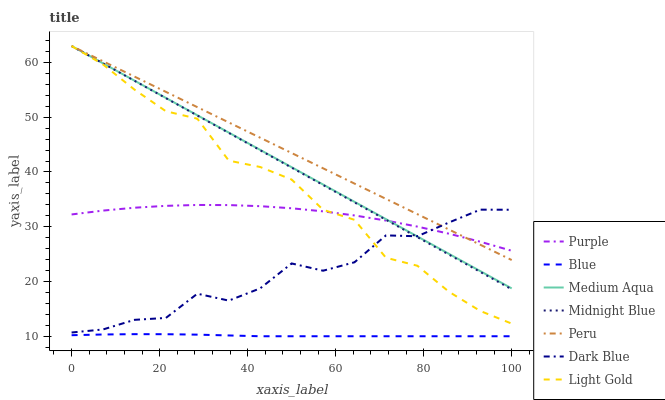Does Midnight Blue have the minimum area under the curve?
Answer yes or no. No. Does Midnight Blue have the maximum area under the curve?
Answer yes or no. No. Is Purple the smoothest?
Answer yes or no. No. Is Purple the roughest?
Answer yes or no. No. Does Midnight Blue have the lowest value?
Answer yes or no. No. Does Purple have the highest value?
Answer yes or no. No. Is Blue less than Midnight Blue?
Answer yes or no. Yes. Is Light Gold greater than Blue?
Answer yes or no. Yes. Does Blue intersect Midnight Blue?
Answer yes or no. No. 